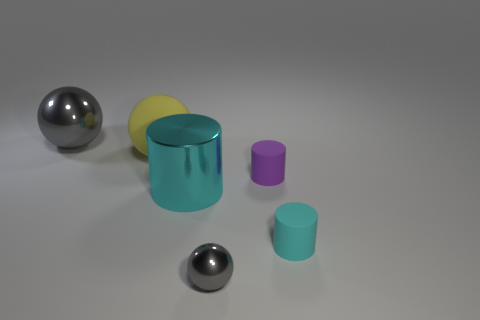There is a big thing that is the same color as the tiny sphere; what is it made of? The large object sharing the same color as the tiny sphere appears to be a cyan-colored cylinder, and given the reflective surface and the context of the image, it is likely made of a material similar to metal, such as aluminum or stainless steel, which is commonly used for creating realistic objects in 3D renderings or simulations. 